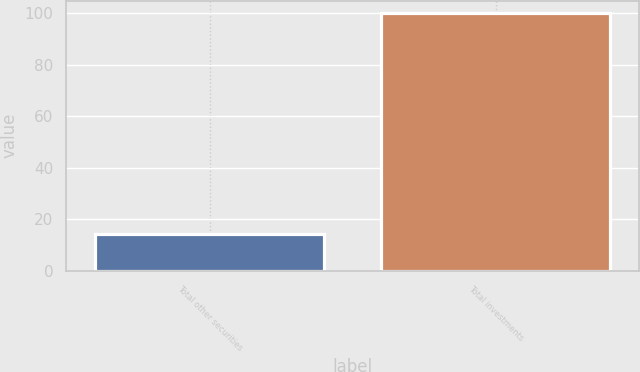<chart> <loc_0><loc_0><loc_500><loc_500><bar_chart><fcel>Total other securities<fcel>Total investments<nl><fcel>14.4<fcel>100<nl></chart> 